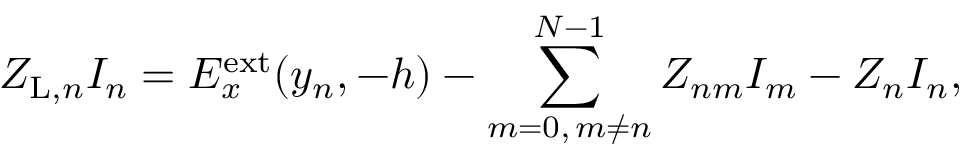<formula> <loc_0><loc_0><loc_500><loc_500>Z _ { L , n } I _ { n } = E _ { x } ^ { e x t } ( y _ { n } , - h ) - \sum _ { m = 0 , \, m \ne n } ^ { N - 1 } Z _ { n m } I _ { m } - Z _ { n } I _ { n } ,</formula> 